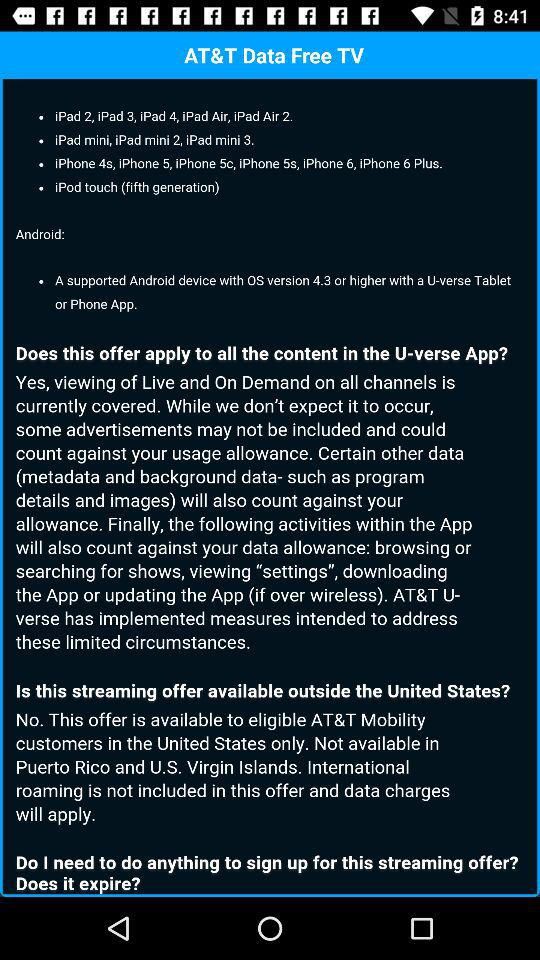How many iPads are there?
When the provided information is insufficient, respond with <no answer>. <no answer> 